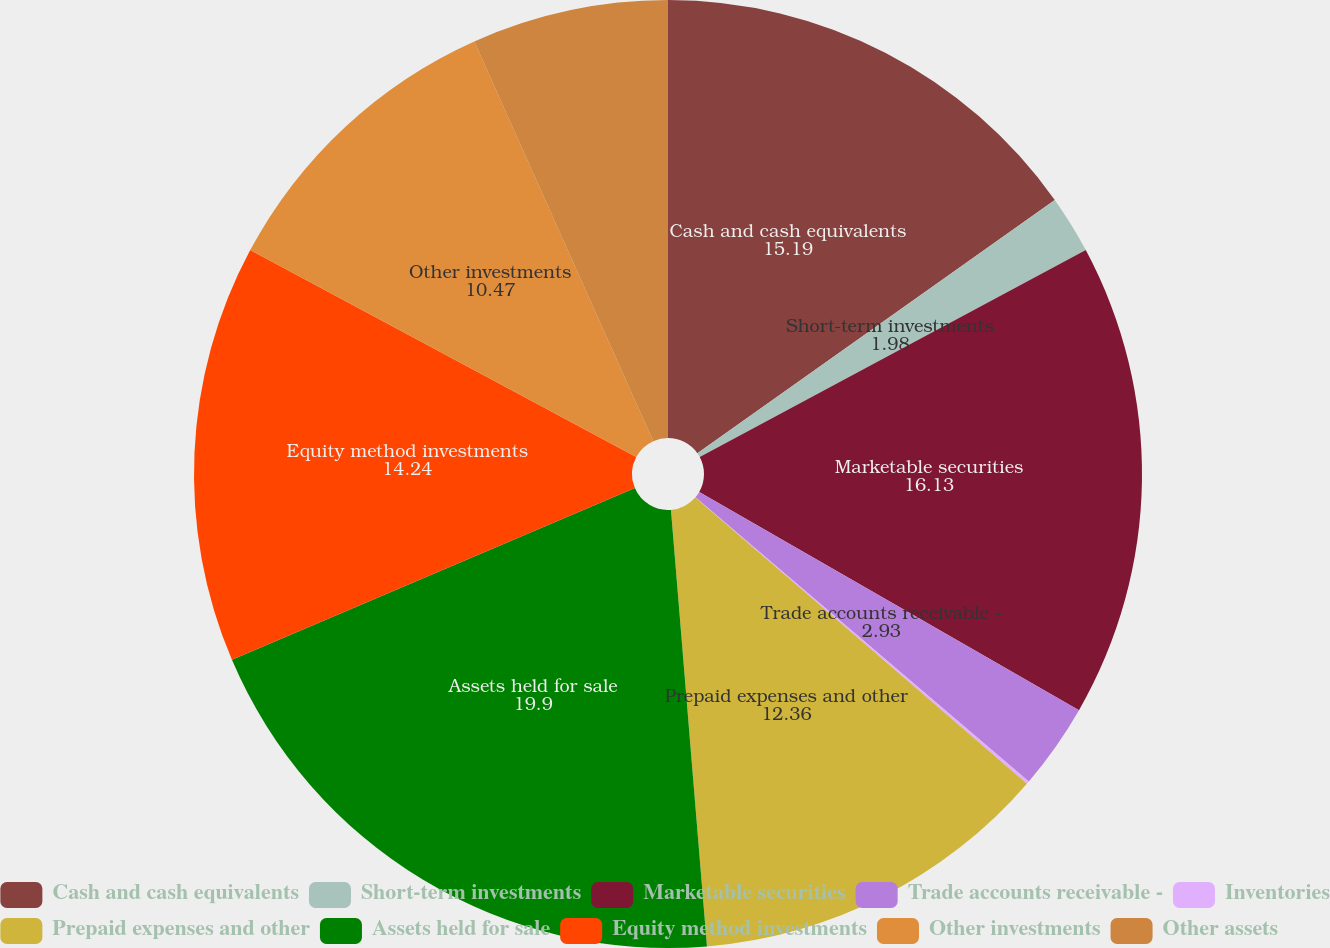<chart> <loc_0><loc_0><loc_500><loc_500><pie_chart><fcel>Cash and cash equivalents<fcel>Short-term investments<fcel>Marketable securities<fcel>Trade accounts receivable -<fcel>Inventories<fcel>Prepaid expenses and other<fcel>Assets held for sale<fcel>Equity method investments<fcel>Other investments<fcel>Other assets<nl><fcel>15.19%<fcel>1.98%<fcel>16.13%<fcel>2.93%<fcel>0.1%<fcel>12.36%<fcel>19.9%<fcel>14.24%<fcel>10.47%<fcel>6.7%<nl></chart> 